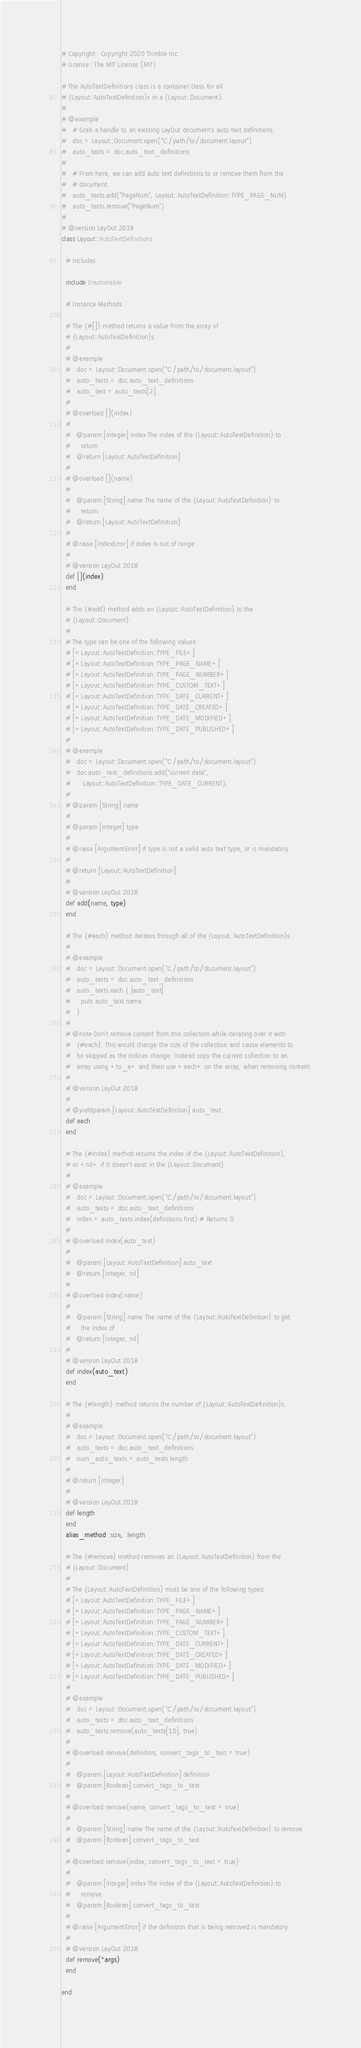<code> <loc_0><loc_0><loc_500><loc_500><_Ruby_># Copyright:: Copyright 2020 Trimble Inc.
# License:: The MIT License (MIT)

# The AutoTextDefinitions class is a container class for all
# {Layout::AutoTextDefinition}s in a {Layout::Document}.
#
# @example
#   # Grab a handle to an existing LayOut document's auto text definitions.
#   doc = Layout::Document.open("C:/path/to/document.layout")
#   auto_texts = doc.auto_text_definitions
#
#   # From here, we can add auto text definitions to or remove them from the
#   # document.
#   auto_texts.add("PageNum", Layout::AutoTextDefinition::TYPE_PAGE_NUM)
#   auto_texts.remove("PageNum")
#
# @version LayOut 2018
class Layout::AutoTextDefinitions

  # Includes

  include Enumerable

  # Instance Methods

  # The {#[]} method returns a value from the array of
  # {Layout::AutoTextDefinition}s.
  #
  # @example
  #   doc = Layout::Document.open("C:/path/to/document.layout")
  #   auto_texts = doc.auto_text_definitions
  #   auto_text = auto_texts[2]
  #
  # @overload [](index)
  #
  #   @param [Integer] index The index of the {Layout::AutoTextDefinition} to
  #     return
  #   @return [Layout::AutoTextDefinition]
  #
  # @overload [](name)
  #
  #   @param [String] name The name of the {Layout::AutoTextDefinition} to
  #     return
  #   @return [Layout::AutoTextDefinition]
  #
  # @raise [IndexError] if index is out of range
  #
  # @version LayOut 2018
  def [](index)
  end

  # The {#add} method adds an {Layout::AutoTextDefinition} to the
  # {Layout::Document}.
  #
  # The type can be one of the following values:
  # [+Layout::AutoTextDefinition::TYPE_FILE+]
  # [+Layout::AutoTextDefinition::TYPE_PAGE_NAME+]
  # [+Layout::AutoTextDefinition::TYPE_PAGE_NUMBER+]
  # [+Layout::AutoTextDefinition::TYPE_CUSTOM_TEXT+]
  # [+Layout::AutoTextDefinition::TYPE_DATE_CURRENT+]
  # [+Layout::AutoTextDefinition::TYPE_DATE_CREATED+]
  # [+Layout::AutoTextDefinition::TYPE_DATE_MODIFIED+]
  # [+Layout::AutoTextDefinition::TYPE_DATE_PUBLISHED+]
  #
  # @example
  #   doc = Layout::Document.open("C:/path/to/document.layout")
  #   doc.auto_text_definitions.add("current date",
  #      Layout::AutoTextDefinition::TYPE_DATE_CURRENT);
  #
  # @param [String] name
  #
  # @param [Integer] type
  #
  # @raise [ArgumentError] if type is not a valid auto text type, or is mandatory.
  #
  # @return [Layout::AutoTextDefinition]
  #
  # @version LayOut 2018
  def add(name, type)
  end

  # The {#each} method iterates through all of the {Layout::AutoTextDefinition}s.
  #
  # @example
  #   doc = Layout::Document.open("C:/path/to/document.layout")
  #   auto_texts = doc.auto_text_definitions
  #   auto_texts.each { |auto_text|
  #     puts auto_text.name
  #   }
  #
  # @note Don't remove content from this collection while iterating over it with
  #   {#each}. This would change the size of the collection and cause elements to
  #   be skipped as the indices change. Instead copy the current collection to an
  #   array using +to_a+ and then use +each+ on the array, when removing content.
  #
  # @version LayOut 2018
  #
  # @yieldparam [Layout::AutoTextDefinition] auto_text
  def each
  end

  # The {#index} method returns the index of the {Layout::AutoTextDefinition},
  # or +nil+ if it doesn't exist in the {Layout::Document}.
  #
  # @example
  #   doc = Layout::Document.open("C:/path/to/document.layout")
  #   auto_texts = doc.auto_text_definitions
  #   index = auto_texts.index(definitions.first) # Returns 0
  #
  # @overload index(auto_text)
  #
  #   @param [Layout::AutoTextDefinition] auto_text
  #   @return [Integer, nil]
  #
  # @overload index(name)
  #
  #   @param [String] name The name of the {Layout::AutoTextDefinition} to get
  #     the index of
  #   @return [Integer, nil]
  #
  # @version LayOut 2018
  def index(auto_text)
  end

  # The {#length} method returns the number of {Layout::AutoTextDefinition}s.
  #
  # @example
  #   doc = Layout::Document.open("C:/path/to/document.layout")
  #   auto_texts = doc.auto_text_definitions
  #   num_auto_texts = auto_texts.length
  #
  # @return [Integer]
  #
  # @version LayOut 2018
  def length
  end
  alias_method :size, :length

  # The {#remove} method removes an {Layout::AutoTextDefinition} from the
  # {Layout::Document}.
  #
  # The {Layout::AutoTextDefinition} must be one of the following types:
  # [+Layout::AutoTextDefinition::TYPE_FILE+]
  # [+Layout::AutoTextDefinition::TYPE_PAGE_NAME+]
  # [+Layout::AutoTextDefinition::TYPE_PAGE_NUMBER+]
  # [+Layout::AutoTextDefinition::TYPE_CUSTOM_TEXT+]
  # [+Layout::AutoTextDefinition::TYPE_DATE_CURRENT+]
  # [+Layout::AutoTextDefinition::TYPE_DATE_CREATED+]
  # [+Layout::AutoTextDefinition::TYPE_DATE_MODIFIED+]
  # [+Layout::AutoTextDefinition::TYPE_DATE_PUBLISHED+]
  #
  # @example
  #   doc = Layout::Document.open("C:/path/to/document.layout")
  #   auto_texts = doc.auto_text_definitions
  #   auto_texts.remove(auto_texts[10], true)
  #
  # @overload remove(definition, convert_tags_to_text = true)
  #
  #   @param [Layout::AutoTextDefinition] definition
  #   @param [Boolean] convert_tags_to_text
  #
  # @overload remove(name, convert_tags_to_text = true)
  #
  #   @param [String] name The name of the {Layout::AutoTextDefinition} to remove
  #   @param [Boolean] convert_tags_to_text
  #
  # @overload remove(index, convert_tags_to_text = true)
  #
  #   @param [Integer] index The index of the {Layout::AutoTextDefinition} to
  #     remove
  #   @param [Boolean] convert_tags_to_text
  #
  # @raise [ArgumentError] if the definition that is being removed is mandatory
  #
  # @version LayOut 2018
  def remove(*args)
  end

end
</code> 